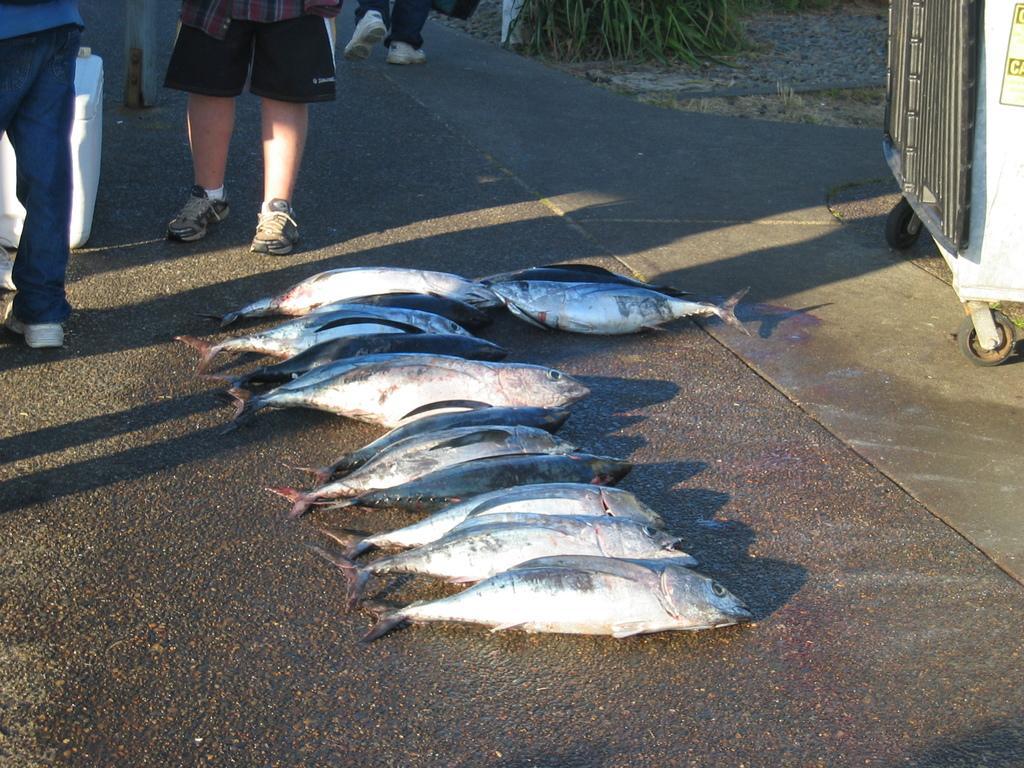In one or two sentences, can you explain what this image depicts? In this image, I can see the fishes, which are kept on the road. There are few people standing. On the right side of the image, that looks like an object with the wheels. At the top of the image, I can see a person walking. This looks like the grass. 